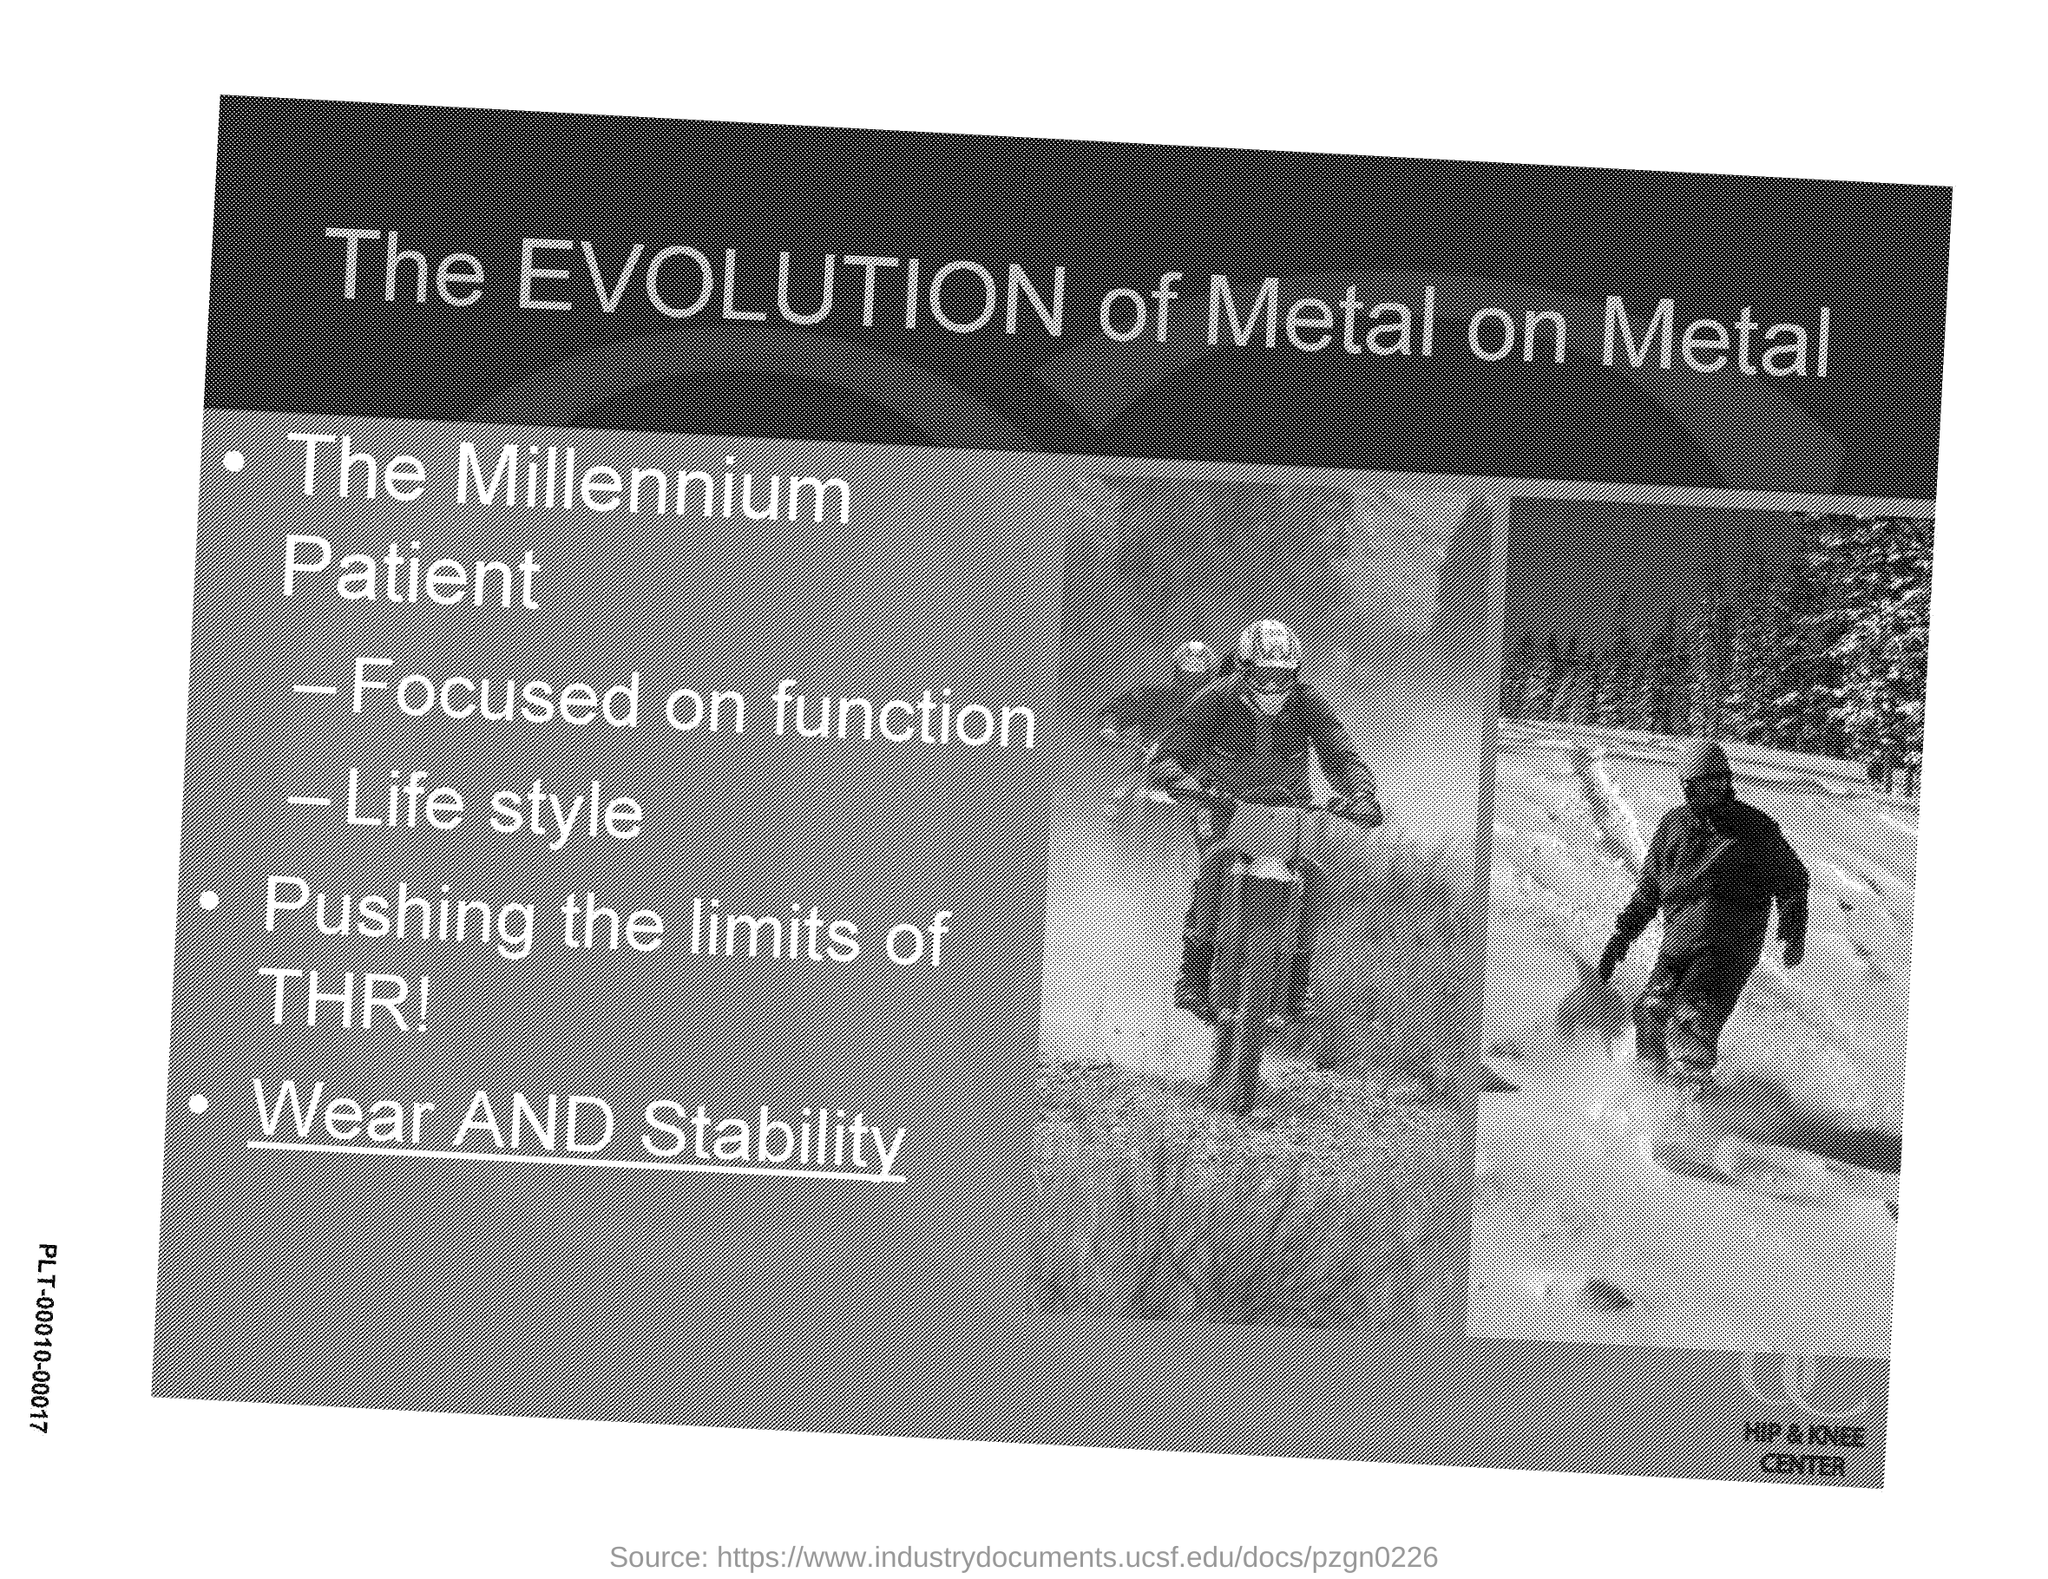Indicate a few pertinent items in this graphic. The title given is 'The EVOLUTION of Metal on Metal'. 